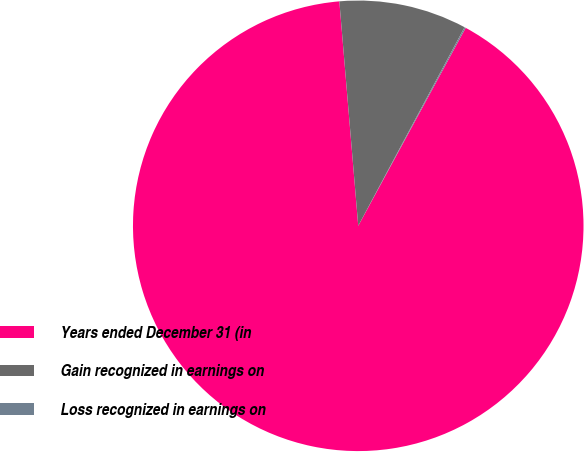Convert chart. <chart><loc_0><loc_0><loc_500><loc_500><pie_chart><fcel>Years ended December 31 (in<fcel>Gain recognized in earnings on<fcel>Loss recognized in earnings on<nl><fcel>90.75%<fcel>9.16%<fcel>0.09%<nl></chart> 